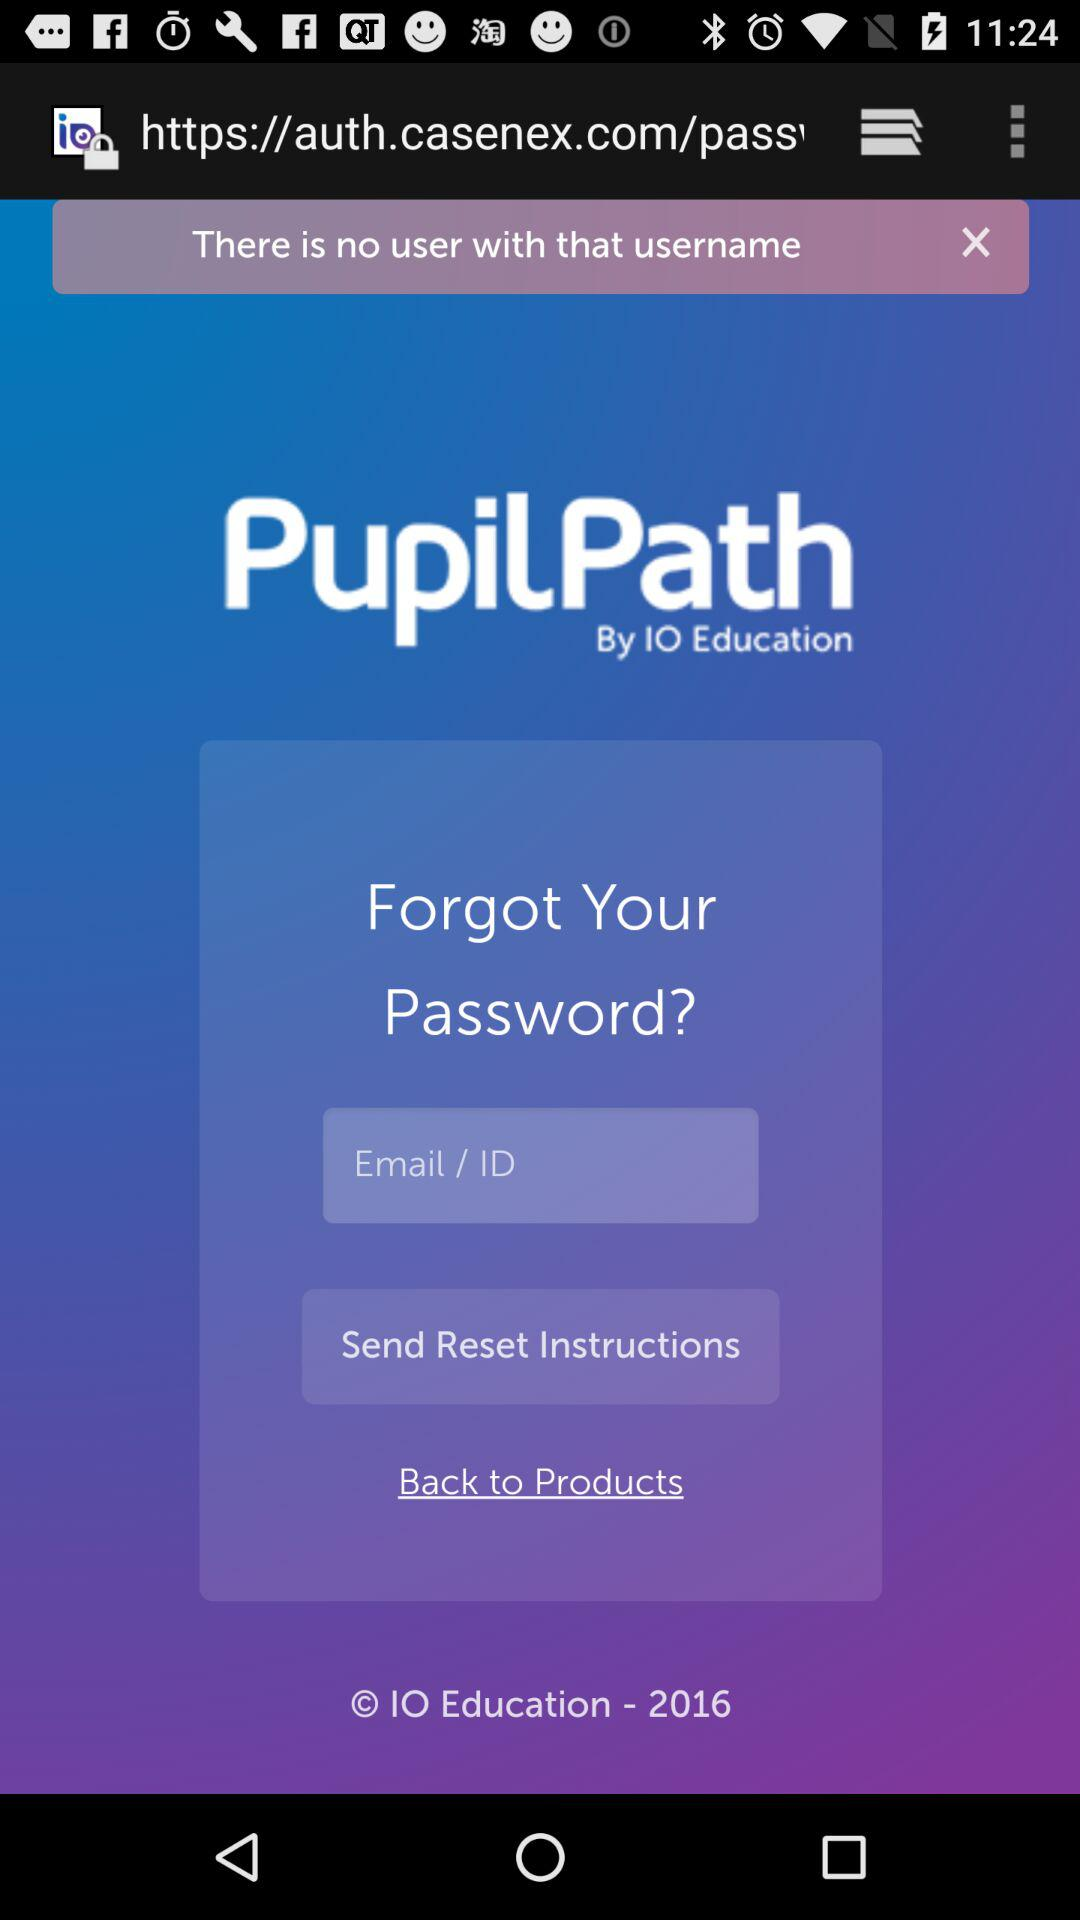What is the application name? The application name is "PupilPath". 